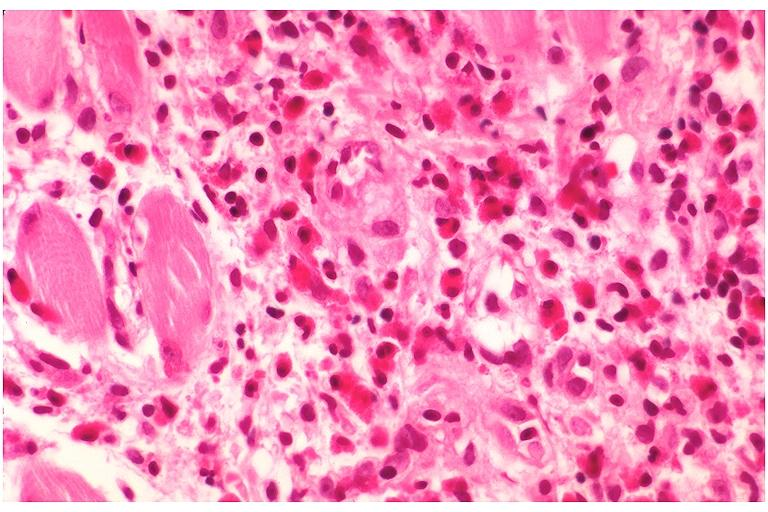does this show langerhans cell histiocytosis eosinophilic granuloma?
Answer the question using a single word or phrase. No 